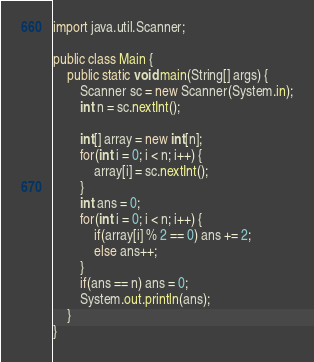Convert code to text. <code><loc_0><loc_0><loc_500><loc_500><_Java_>import java.util.Scanner;

public class Main {
	public static void main(String[] args) {
		Scanner sc = new Scanner(System.in);
		int n = sc.nextInt();

		int[] array = new int[n];
		for(int i = 0; i < n; i++) {
			array[i] = sc.nextInt();
		}
		int ans = 0;
		for(int i = 0; i < n; i++) {
			if(array[i] % 2 == 0) ans += 2;
			else ans++;
		}
		if(ans == n) ans = 0;
		System.out.println(ans);
	}
}
</code> 